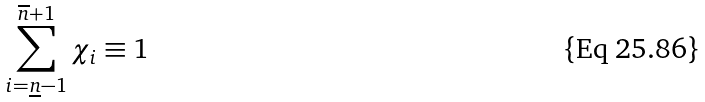Convert formula to latex. <formula><loc_0><loc_0><loc_500><loc_500>\sum _ { i = \underline { n } - 1 } ^ { \overline { n } + 1 } \chi _ { i } \equiv 1</formula> 